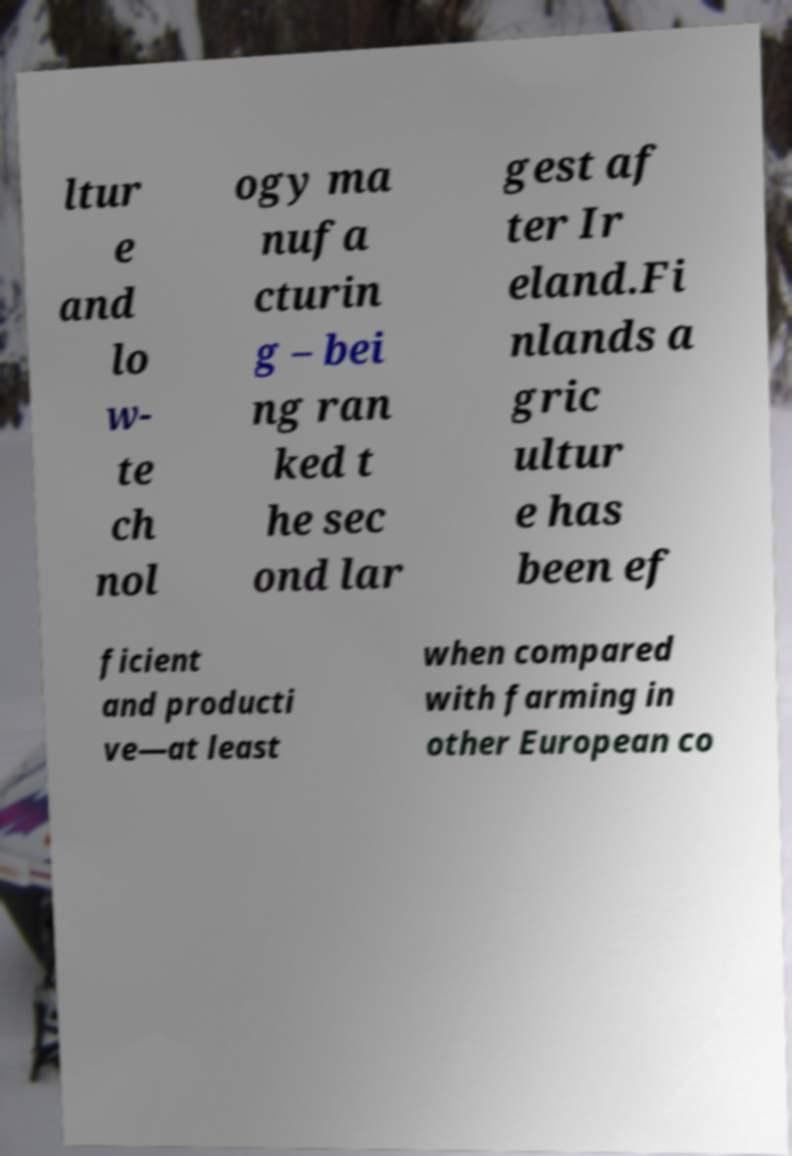Please identify and transcribe the text found in this image. ltur e and lo w- te ch nol ogy ma nufa cturin g – bei ng ran ked t he sec ond lar gest af ter Ir eland.Fi nlands a gric ultur e has been ef ficient and producti ve—at least when compared with farming in other European co 